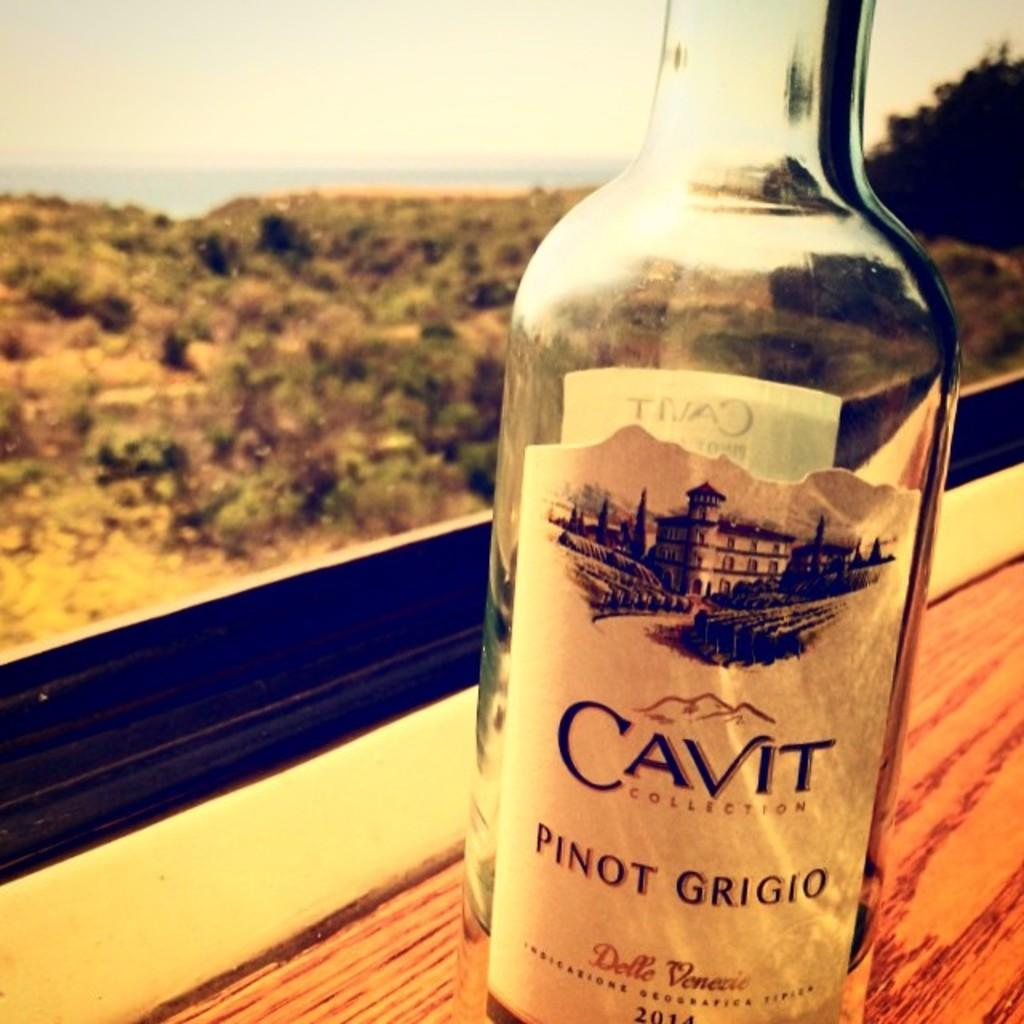Provide a one-sentence caption for the provided image. A near empty bottle of Cavit Pinot Grigio sits on a window ledge. 